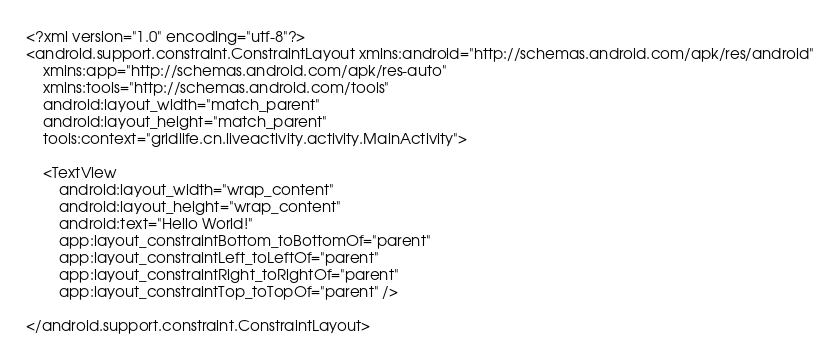Convert code to text. <code><loc_0><loc_0><loc_500><loc_500><_XML_><?xml version="1.0" encoding="utf-8"?>
<android.support.constraint.ConstraintLayout xmlns:android="http://schemas.android.com/apk/res/android"
    xmlns:app="http://schemas.android.com/apk/res-auto"
    xmlns:tools="http://schemas.android.com/tools"
    android:layout_width="match_parent"
    android:layout_height="match_parent"
    tools:context="gridlife.cn.liveactivity.activity.MainActivity">

    <TextView
        android:layout_width="wrap_content"
        android:layout_height="wrap_content"
        android:text="Hello World!"
        app:layout_constraintBottom_toBottomOf="parent"
        app:layout_constraintLeft_toLeftOf="parent"
        app:layout_constraintRight_toRightOf="parent"
        app:layout_constraintTop_toTopOf="parent" />

</android.support.constraint.ConstraintLayout>
</code> 